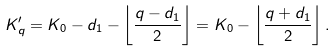Convert formula to latex. <formula><loc_0><loc_0><loc_500><loc_500>K _ { q } ^ { \prime } = K _ { 0 } - d _ { 1 } - \left \lfloor { \frac { q - d _ { 1 } } { 2 } } \right \rfloor = K _ { 0 } - \left \lfloor { \frac { q + d _ { 1 } } { 2 } } \right \rfloor .</formula> 